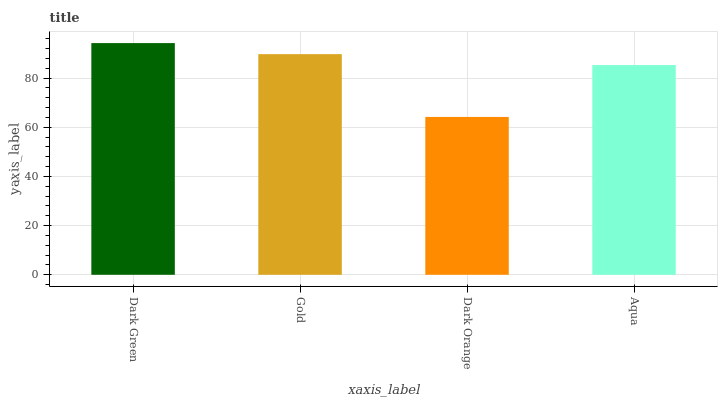Is Dark Orange the minimum?
Answer yes or no. Yes. Is Dark Green the maximum?
Answer yes or no. Yes. Is Gold the minimum?
Answer yes or no. No. Is Gold the maximum?
Answer yes or no. No. Is Dark Green greater than Gold?
Answer yes or no. Yes. Is Gold less than Dark Green?
Answer yes or no. Yes. Is Gold greater than Dark Green?
Answer yes or no. No. Is Dark Green less than Gold?
Answer yes or no. No. Is Gold the high median?
Answer yes or no. Yes. Is Aqua the low median?
Answer yes or no. Yes. Is Dark Orange the high median?
Answer yes or no. No. Is Dark Green the low median?
Answer yes or no. No. 